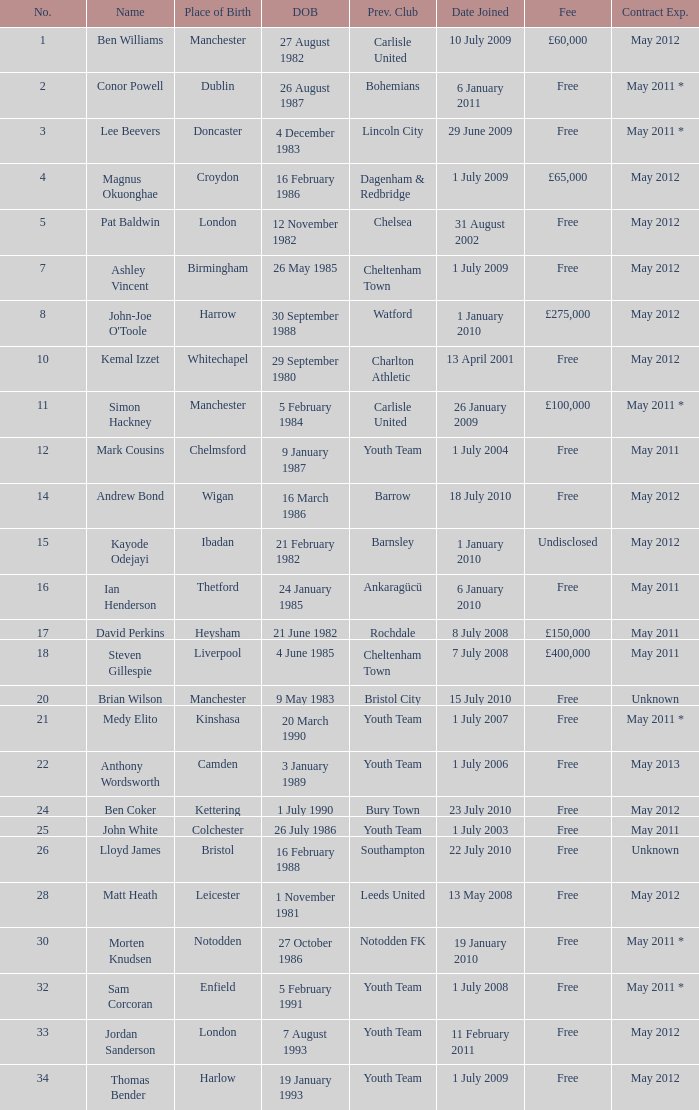What is the fee for ankaragücü previous club Free. 